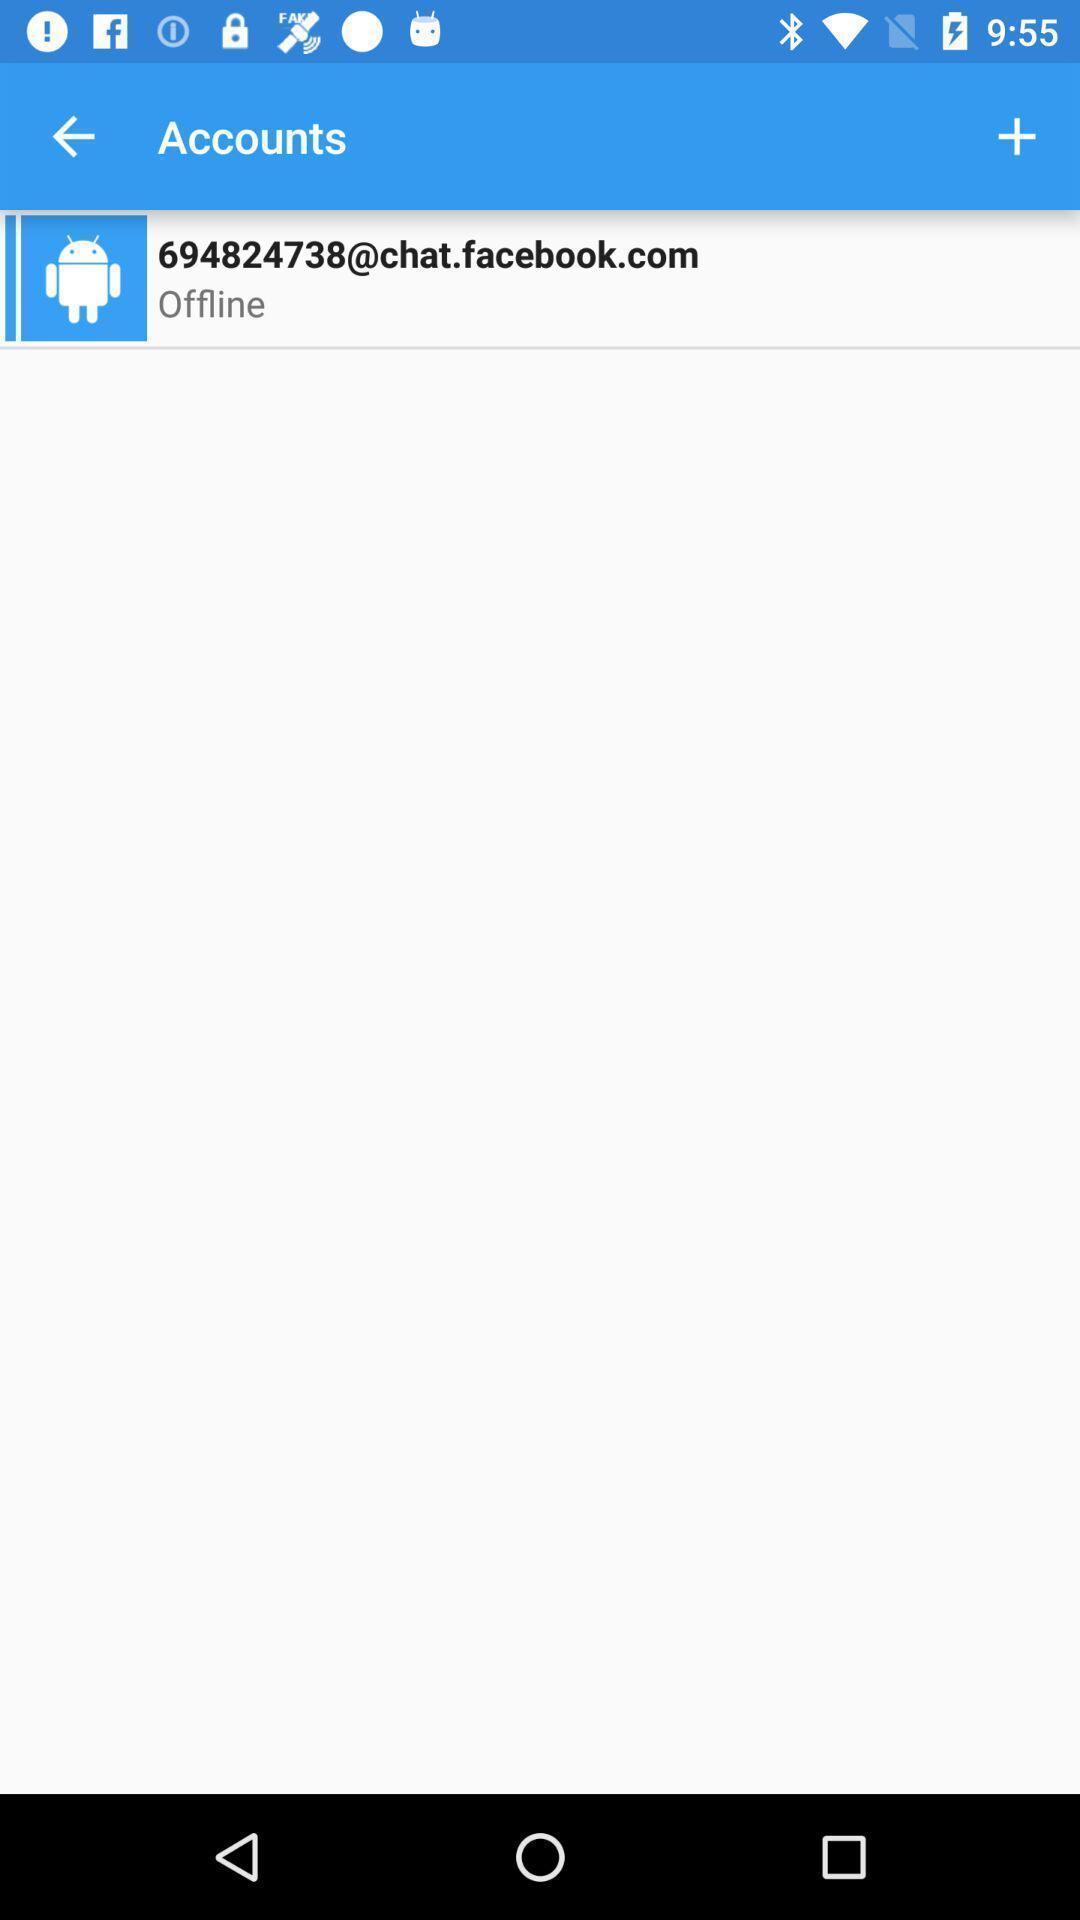Explain the elements present in this screenshot. Page displaying accounts in app. 